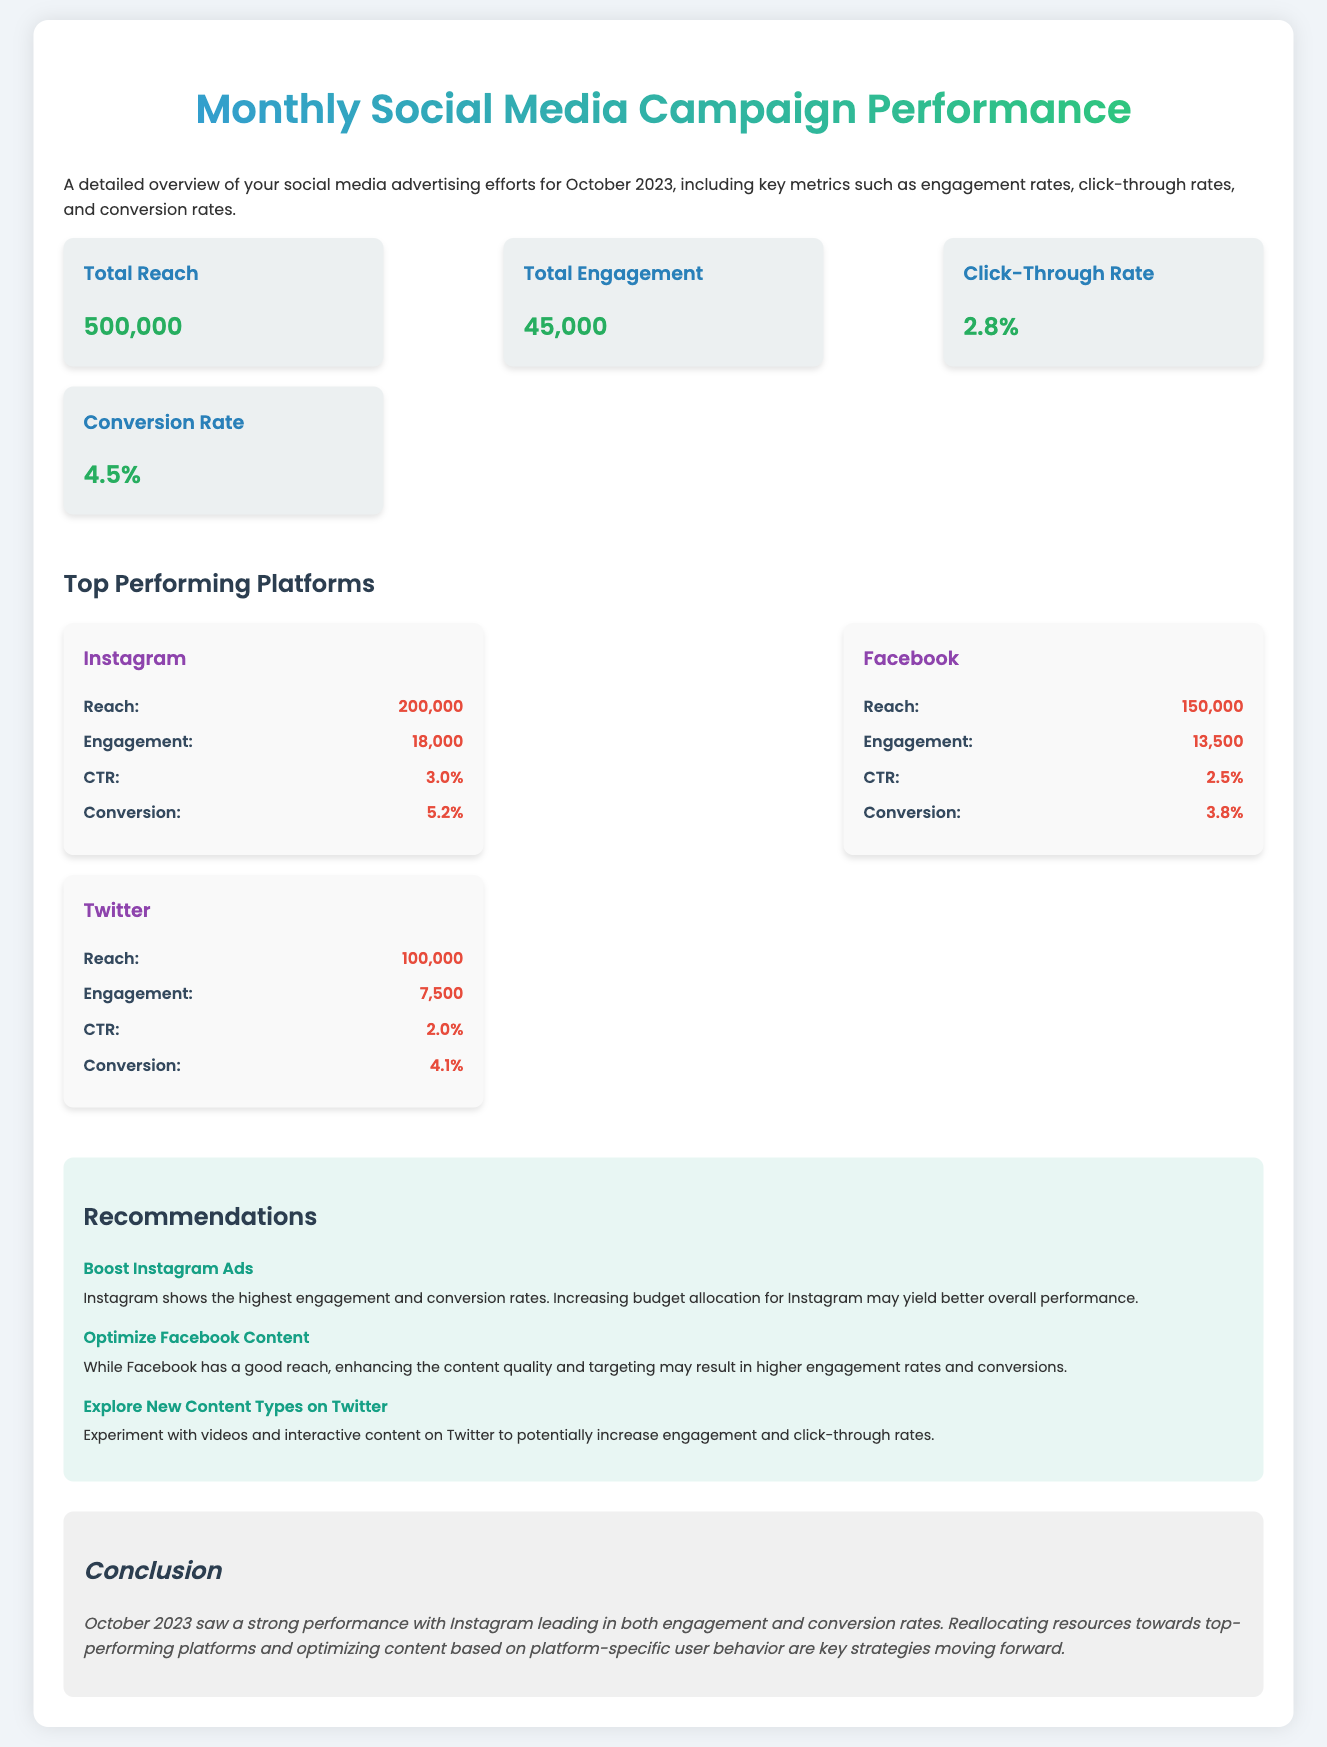What is the total reach? The total reach is stated directly in the summary section of the document as 500,000.
Answer: 500,000 What is the click-through rate for Instagram? The click-through rate (CTR) for Instagram is provided in the platform performance section specifically for Instagram as 3.0%.
Answer: 3.0% What are the total engagements? The total engagements are mentioned in the summary section as 45,000.
Answer: 45,000 What platform has the highest conversion rate? The conversion rates for each platform indicate that Instagram has the highest at 5.2%.
Answer: Instagram What is the recommendation for Facebook? The recommendation for Facebook suggests optimizing content for higher engagement and conversions.
Answer: Optimize Facebook Content How many total engagements does Twitter have? The total engagements for Twitter are listed in the platform performance section as 7,500.
Answer: 7,500 What is the conversion rate according to the summary? The summary section lists the conversion rate as 4.5%.
Answer: 4.5% Which platform's reach is 150,000? The reach of 150,000 is specifically mentioned for Facebook in the platform performance section.
Answer: Facebook What is the conclusion about October 2023 performance? The conclusion summarizes that Instagram led in both engagement and conversion rates for the month.
Answer: Instagram 